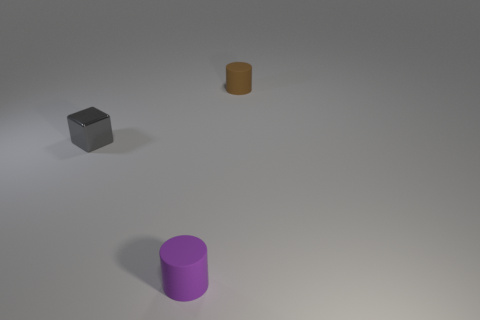Subtract 1 blocks. How many blocks are left? 0 Add 2 purple cylinders. How many objects exist? 5 Subtract all brown cylinders. How many cylinders are left? 1 Subtract all large purple rubber objects. Subtract all small brown rubber cylinders. How many objects are left? 2 Add 1 purple rubber cylinders. How many purple rubber cylinders are left? 2 Add 3 tiny rubber cylinders. How many tiny rubber cylinders exist? 5 Subtract 0 yellow cubes. How many objects are left? 3 Subtract all cylinders. How many objects are left? 1 Subtract all purple cylinders. Subtract all brown spheres. How many cylinders are left? 1 Subtract all green cylinders. How many yellow cubes are left? 0 